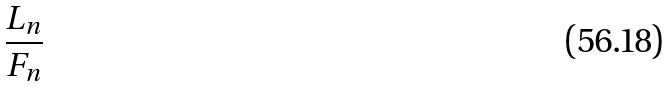<formula> <loc_0><loc_0><loc_500><loc_500>\frac { L _ { n } } { F _ { n } }</formula> 